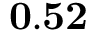Convert formula to latex. <formula><loc_0><loc_0><loc_500><loc_500>0 . 5 2</formula> 